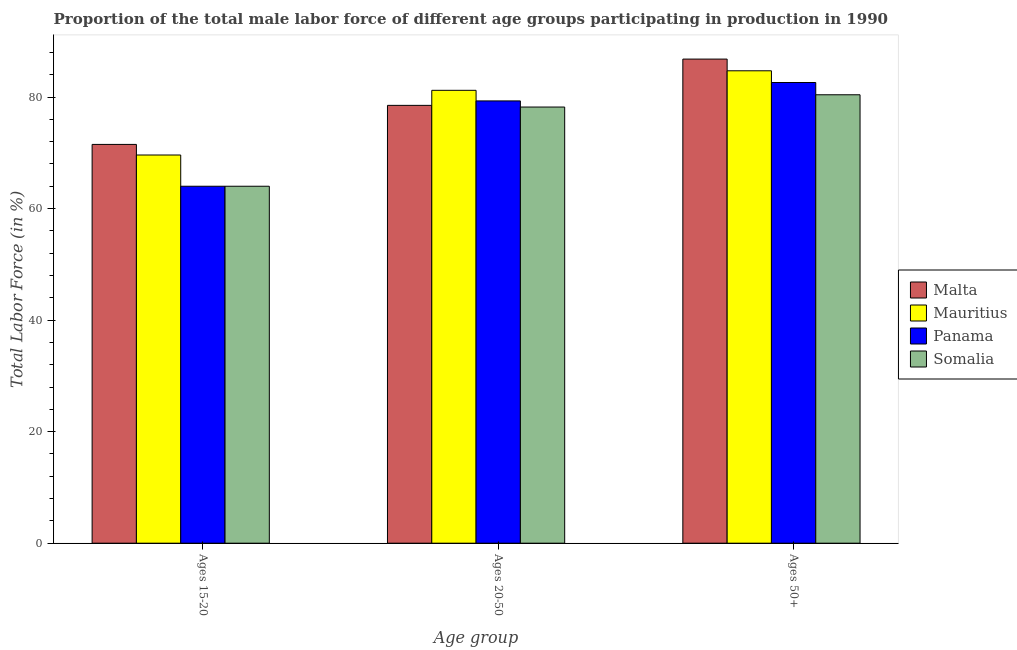How many different coloured bars are there?
Offer a terse response. 4. Are the number of bars on each tick of the X-axis equal?
Make the answer very short. Yes. How many bars are there on the 1st tick from the right?
Your answer should be very brief. 4. What is the label of the 2nd group of bars from the left?
Your answer should be very brief. Ages 20-50. What is the percentage of male labor force within the age group 15-20 in Malta?
Your answer should be very brief. 71.5. Across all countries, what is the maximum percentage of male labor force above age 50?
Keep it short and to the point. 86.8. Across all countries, what is the minimum percentage of male labor force above age 50?
Offer a very short reply. 80.4. In which country was the percentage of male labor force within the age group 15-20 maximum?
Offer a terse response. Malta. In which country was the percentage of male labor force within the age group 15-20 minimum?
Make the answer very short. Panama. What is the total percentage of male labor force within the age group 20-50 in the graph?
Provide a short and direct response. 317.2. What is the difference between the percentage of male labor force within the age group 20-50 in Mauritius and that in Malta?
Your answer should be compact. 2.7. What is the difference between the percentage of male labor force within the age group 15-20 in Malta and the percentage of male labor force above age 50 in Panama?
Ensure brevity in your answer.  -11.1. What is the average percentage of male labor force above age 50 per country?
Give a very brief answer. 83.62. What is the difference between the percentage of male labor force within the age group 15-20 and percentage of male labor force above age 50 in Malta?
Offer a terse response. -15.3. In how many countries, is the percentage of male labor force above age 50 greater than 84 %?
Offer a very short reply. 2. What is the ratio of the percentage of male labor force within the age group 20-50 in Malta to that in Mauritius?
Your response must be concise. 0.97. Is the difference between the percentage of male labor force above age 50 in Panama and Somalia greater than the difference between the percentage of male labor force within the age group 20-50 in Panama and Somalia?
Provide a short and direct response. Yes. What is the difference between the highest and the second highest percentage of male labor force within the age group 15-20?
Offer a very short reply. 1.9. What is the difference between the highest and the lowest percentage of male labor force above age 50?
Your answer should be compact. 6.4. What does the 4th bar from the left in Ages 50+ represents?
Keep it short and to the point. Somalia. What does the 3rd bar from the right in Ages 15-20 represents?
Offer a very short reply. Mauritius. Is it the case that in every country, the sum of the percentage of male labor force within the age group 15-20 and percentage of male labor force within the age group 20-50 is greater than the percentage of male labor force above age 50?
Offer a terse response. Yes. How many bars are there?
Make the answer very short. 12. Are all the bars in the graph horizontal?
Your answer should be very brief. No. How many countries are there in the graph?
Give a very brief answer. 4. Are the values on the major ticks of Y-axis written in scientific E-notation?
Provide a short and direct response. No. Does the graph contain grids?
Make the answer very short. No. Where does the legend appear in the graph?
Offer a terse response. Center right. How many legend labels are there?
Your answer should be compact. 4. How are the legend labels stacked?
Keep it short and to the point. Vertical. What is the title of the graph?
Provide a short and direct response. Proportion of the total male labor force of different age groups participating in production in 1990. Does "Serbia" appear as one of the legend labels in the graph?
Offer a very short reply. No. What is the label or title of the X-axis?
Provide a succinct answer. Age group. What is the label or title of the Y-axis?
Give a very brief answer. Total Labor Force (in %). What is the Total Labor Force (in %) of Malta in Ages 15-20?
Your answer should be very brief. 71.5. What is the Total Labor Force (in %) of Mauritius in Ages 15-20?
Your response must be concise. 69.6. What is the Total Labor Force (in %) in Somalia in Ages 15-20?
Offer a very short reply. 64. What is the Total Labor Force (in %) in Malta in Ages 20-50?
Keep it short and to the point. 78.5. What is the Total Labor Force (in %) of Mauritius in Ages 20-50?
Your answer should be very brief. 81.2. What is the Total Labor Force (in %) in Panama in Ages 20-50?
Ensure brevity in your answer.  79.3. What is the Total Labor Force (in %) of Somalia in Ages 20-50?
Your answer should be compact. 78.2. What is the Total Labor Force (in %) in Malta in Ages 50+?
Your response must be concise. 86.8. What is the Total Labor Force (in %) of Mauritius in Ages 50+?
Offer a terse response. 84.7. What is the Total Labor Force (in %) of Panama in Ages 50+?
Your answer should be compact. 82.6. What is the Total Labor Force (in %) of Somalia in Ages 50+?
Offer a terse response. 80.4. Across all Age group, what is the maximum Total Labor Force (in %) in Malta?
Ensure brevity in your answer.  86.8. Across all Age group, what is the maximum Total Labor Force (in %) in Mauritius?
Your response must be concise. 84.7. Across all Age group, what is the maximum Total Labor Force (in %) of Panama?
Ensure brevity in your answer.  82.6. Across all Age group, what is the maximum Total Labor Force (in %) of Somalia?
Your answer should be compact. 80.4. Across all Age group, what is the minimum Total Labor Force (in %) in Malta?
Ensure brevity in your answer.  71.5. Across all Age group, what is the minimum Total Labor Force (in %) of Mauritius?
Keep it short and to the point. 69.6. Across all Age group, what is the minimum Total Labor Force (in %) of Panama?
Keep it short and to the point. 64. Across all Age group, what is the minimum Total Labor Force (in %) of Somalia?
Offer a terse response. 64. What is the total Total Labor Force (in %) in Malta in the graph?
Offer a very short reply. 236.8. What is the total Total Labor Force (in %) in Mauritius in the graph?
Make the answer very short. 235.5. What is the total Total Labor Force (in %) in Panama in the graph?
Your answer should be compact. 225.9. What is the total Total Labor Force (in %) of Somalia in the graph?
Offer a very short reply. 222.6. What is the difference between the Total Labor Force (in %) in Mauritius in Ages 15-20 and that in Ages 20-50?
Provide a succinct answer. -11.6. What is the difference between the Total Labor Force (in %) in Panama in Ages 15-20 and that in Ages 20-50?
Provide a succinct answer. -15.3. What is the difference between the Total Labor Force (in %) in Malta in Ages 15-20 and that in Ages 50+?
Offer a terse response. -15.3. What is the difference between the Total Labor Force (in %) in Mauritius in Ages 15-20 and that in Ages 50+?
Offer a terse response. -15.1. What is the difference between the Total Labor Force (in %) of Panama in Ages 15-20 and that in Ages 50+?
Your answer should be compact. -18.6. What is the difference between the Total Labor Force (in %) in Somalia in Ages 15-20 and that in Ages 50+?
Your response must be concise. -16.4. What is the difference between the Total Labor Force (in %) in Panama in Ages 20-50 and that in Ages 50+?
Your response must be concise. -3.3. What is the difference between the Total Labor Force (in %) in Somalia in Ages 20-50 and that in Ages 50+?
Offer a terse response. -2.2. What is the difference between the Total Labor Force (in %) of Malta in Ages 15-20 and the Total Labor Force (in %) of Somalia in Ages 20-50?
Offer a terse response. -6.7. What is the difference between the Total Labor Force (in %) in Mauritius in Ages 15-20 and the Total Labor Force (in %) in Panama in Ages 20-50?
Provide a short and direct response. -9.7. What is the difference between the Total Labor Force (in %) of Mauritius in Ages 15-20 and the Total Labor Force (in %) of Somalia in Ages 20-50?
Your answer should be compact. -8.6. What is the difference between the Total Labor Force (in %) in Malta in Ages 15-20 and the Total Labor Force (in %) in Somalia in Ages 50+?
Ensure brevity in your answer.  -8.9. What is the difference between the Total Labor Force (in %) of Panama in Ages 15-20 and the Total Labor Force (in %) of Somalia in Ages 50+?
Provide a short and direct response. -16.4. What is the difference between the Total Labor Force (in %) of Malta in Ages 20-50 and the Total Labor Force (in %) of Mauritius in Ages 50+?
Give a very brief answer. -6.2. What is the difference between the Total Labor Force (in %) in Malta in Ages 20-50 and the Total Labor Force (in %) in Panama in Ages 50+?
Your response must be concise. -4.1. What is the difference between the Total Labor Force (in %) of Malta in Ages 20-50 and the Total Labor Force (in %) of Somalia in Ages 50+?
Your response must be concise. -1.9. What is the difference between the Total Labor Force (in %) of Mauritius in Ages 20-50 and the Total Labor Force (in %) of Panama in Ages 50+?
Your answer should be compact. -1.4. What is the average Total Labor Force (in %) of Malta per Age group?
Offer a very short reply. 78.93. What is the average Total Labor Force (in %) in Mauritius per Age group?
Make the answer very short. 78.5. What is the average Total Labor Force (in %) in Panama per Age group?
Your response must be concise. 75.3. What is the average Total Labor Force (in %) in Somalia per Age group?
Keep it short and to the point. 74.2. What is the difference between the Total Labor Force (in %) of Malta and Total Labor Force (in %) of Mauritius in Ages 15-20?
Ensure brevity in your answer.  1.9. What is the difference between the Total Labor Force (in %) of Malta and Total Labor Force (in %) of Panama in Ages 15-20?
Offer a terse response. 7.5. What is the difference between the Total Labor Force (in %) in Mauritius and Total Labor Force (in %) in Panama in Ages 15-20?
Keep it short and to the point. 5.6. What is the difference between the Total Labor Force (in %) of Malta and Total Labor Force (in %) of Somalia in Ages 20-50?
Provide a short and direct response. 0.3. What is the difference between the Total Labor Force (in %) of Mauritius and Total Labor Force (in %) of Panama in Ages 20-50?
Make the answer very short. 1.9. What is the difference between the Total Labor Force (in %) of Panama and Total Labor Force (in %) of Somalia in Ages 20-50?
Keep it short and to the point. 1.1. What is the difference between the Total Labor Force (in %) of Malta and Total Labor Force (in %) of Mauritius in Ages 50+?
Provide a short and direct response. 2.1. What is the difference between the Total Labor Force (in %) of Malta and Total Labor Force (in %) of Somalia in Ages 50+?
Your answer should be very brief. 6.4. What is the difference between the Total Labor Force (in %) of Mauritius and Total Labor Force (in %) of Somalia in Ages 50+?
Make the answer very short. 4.3. What is the ratio of the Total Labor Force (in %) in Malta in Ages 15-20 to that in Ages 20-50?
Give a very brief answer. 0.91. What is the ratio of the Total Labor Force (in %) of Panama in Ages 15-20 to that in Ages 20-50?
Your response must be concise. 0.81. What is the ratio of the Total Labor Force (in %) of Somalia in Ages 15-20 to that in Ages 20-50?
Make the answer very short. 0.82. What is the ratio of the Total Labor Force (in %) in Malta in Ages 15-20 to that in Ages 50+?
Offer a very short reply. 0.82. What is the ratio of the Total Labor Force (in %) of Mauritius in Ages 15-20 to that in Ages 50+?
Provide a short and direct response. 0.82. What is the ratio of the Total Labor Force (in %) of Panama in Ages 15-20 to that in Ages 50+?
Give a very brief answer. 0.77. What is the ratio of the Total Labor Force (in %) of Somalia in Ages 15-20 to that in Ages 50+?
Your response must be concise. 0.8. What is the ratio of the Total Labor Force (in %) of Malta in Ages 20-50 to that in Ages 50+?
Your response must be concise. 0.9. What is the ratio of the Total Labor Force (in %) of Mauritius in Ages 20-50 to that in Ages 50+?
Your answer should be compact. 0.96. What is the ratio of the Total Labor Force (in %) of Somalia in Ages 20-50 to that in Ages 50+?
Offer a very short reply. 0.97. What is the difference between the highest and the second highest Total Labor Force (in %) of Mauritius?
Give a very brief answer. 3.5. What is the difference between the highest and the second highest Total Labor Force (in %) in Somalia?
Provide a succinct answer. 2.2. What is the difference between the highest and the lowest Total Labor Force (in %) of Somalia?
Make the answer very short. 16.4. 